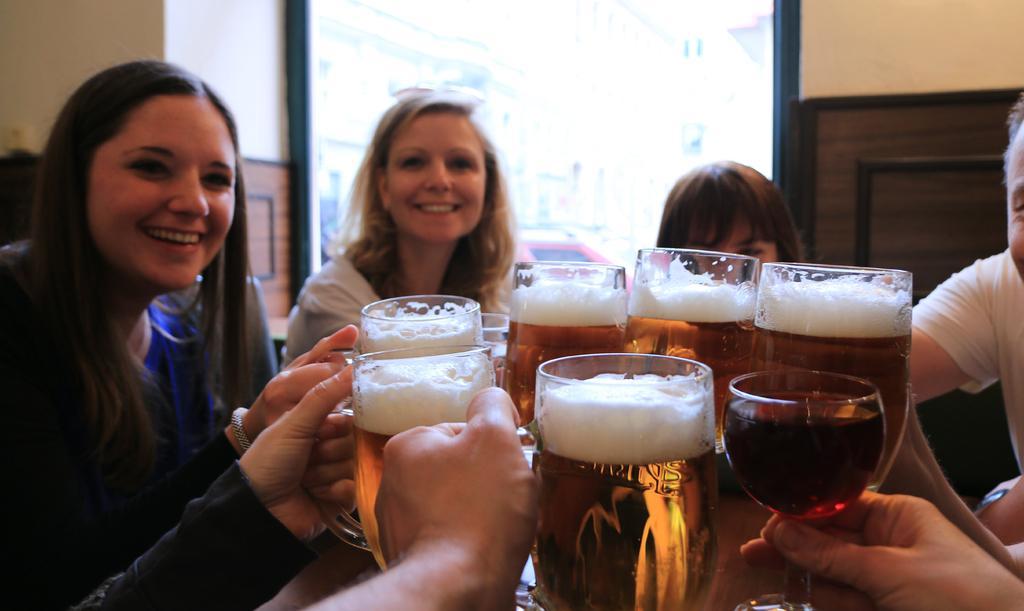Please provide a concise description of this image. In this picture there are many people sitting on the table and clinking their glasses together. In the background we observe a glass door. 